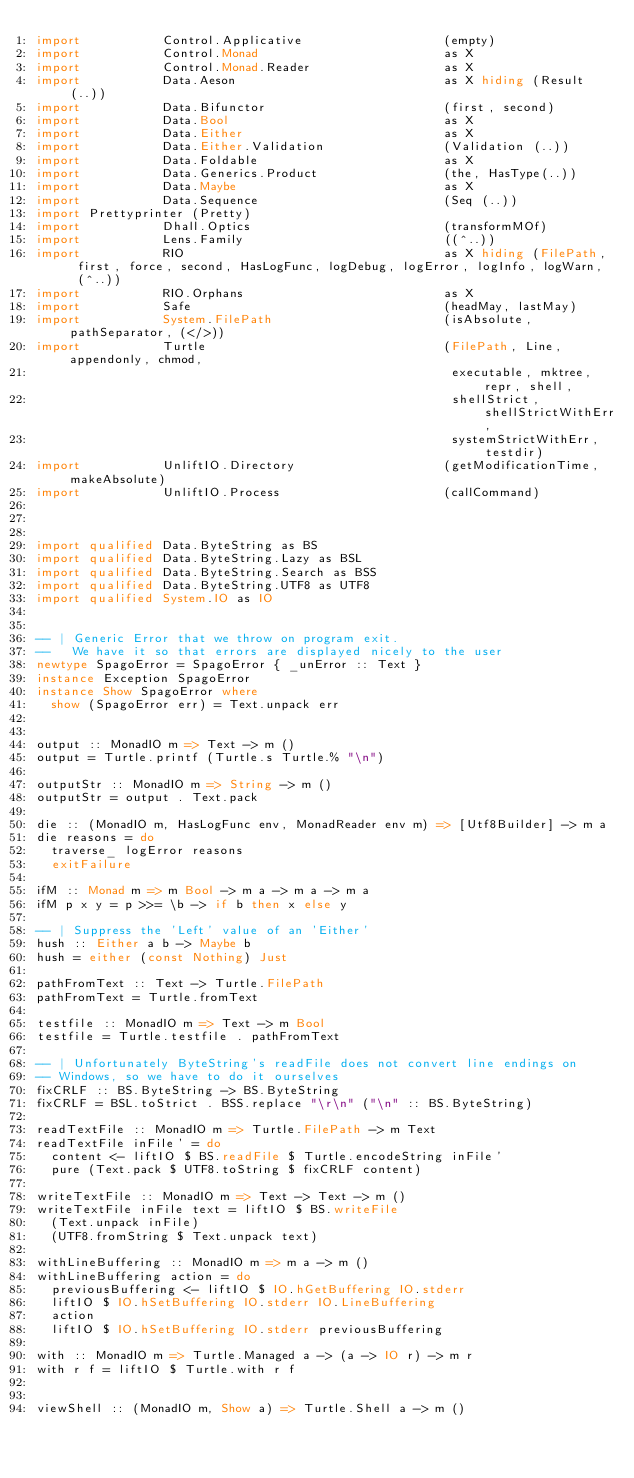<code> <loc_0><loc_0><loc_500><loc_500><_Haskell_>import           Control.Applicative                   (empty)
import           Control.Monad                         as X
import           Control.Monad.Reader                  as X
import           Data.Aeson                            as X hiding (Result (..))
import           Data.Bifunctor                        (first, second)
import           Data.Bool                             as X
import           Data.Either                           as X
import           Data.Either.Validation                (Validation (..))
import           Data.Foldable                         as X
import           Data.Generics.Product                 (the, HasType(..))
import           Data.Maybe                            as X
import           Data.Sequence                         (Seq (..))
import Prettyprinter (Pretty)
import           Dhall.Optics                          (transformMOf)
import           Lens.Family                           ((^..))
import           RIO                                   as X hiding (FilePath, first, force, second, HasLogFunc, logDebug, logError, logInfo, logWarn, (^..))
import           RIO.Orphans                           as X
import           Safe                                  (headMay, lastMay)
import           System.FilePath                       (isAbsolute, pathSeparator, (</>))
import           Turtle                                (FilePath, Line, appendonly, chmod,
                                                        executable, mktree, repr, shell,
                                                        shellStrict, shellStrictWithErr,
                                                        systemStrictWithErr, testdir)
import           UnliftIO.Directory                    (getModificationTime, makeAbsolute)
import           UnliftIO.Process                      (callCommand)



import qualified Data.ByteString as BS
import qualified Data.ByteString.Lazy as BSL
import qualified Data.ByteString.Search as BSS
import qualified Data.ByteString.UTF8 as UTF8
import qualified System.IO as IO


-- | Generic Error that we throw on program exit.
--   We have it so that errors are displayed nicely to the user
newtype SpagoError = SpagoError { _unError :: Text }
instance Exception SpagoError
instance Show SpagoError where
  show (SpagoError err) = Text.unpack err


output :: MonadIO m => Text -> m ()
output = Turtle.printf (Turtle.s Turtle.% "\n")

outputStr :: MonadIO m => String -> m ()
outputStr = output . Text.pack

die :: (MonadIO m, HasLogFunc env, MonadReader env m) => [Utf8Builder] -> m a
die reasons = do
  traverse_ logError reasons
  exitFailure

ifM :: Monad m => m Bool -> m a -> m a -> m a
ifM p x y = p >>= \b -> if b then x else y

-- | Suppress the 'Left' value of an 'Either'
hush :: Either a b -> Maybe b
hush = either (const Nothing) Just

pathFromText :: Text -> Turtle.FilePath
pathFromText = Turtle.fromText

testfile :: MonadIO m => Text -> m Bool
testfile = Turtle.testfile . pathFromText

-- | Unfortunately ByteString's readFile does not convert line endings on
-- Windows, so we have to do it ourselves
fixCRLF :: BS.ByteString -> BS.ByteString
fixCRLF = BSL.toStrict . BSS.replace "\r\n" ("\n" :: BS.ByteString)

readTextFile :: MonadIO m => Turtle.FilePath -> m Text
readTextFile inFile' = do
  content <- liftIO $ BS.readFile $ Turtle.encodeString inFile'
  pure (Text.pack $ UTF8.toString $ fixCRLF content)

writeTextFile :: MonadIO m => Text -> Text -> m ()
writeTextFile inFile text = liftIO $ BS.writeFile
  (Text.unpack inFile)
  (UTF8.fromString $ Text.unpack text)

withLineBuffering :: MonadIO m => m a -> m ()
withLineBuffering action = do
  previousBuffering <- liftIO $ IO.hGetBuffering IO.stderr
  liftIO $ IO.hSetBuffering IO.stderr IO.LineBuffering
  action
  liftIO $ IO.hSetBuffering IO.stderr previousBuffering

with :: MonadIO m => Turtle.Managed a -> (a -> IO r) -> m r
with r f = liftIO $ Turtle.with r f


viewShell :: (MonadIO m, Show a) => Turtle.Shell a -> m ()</code> 